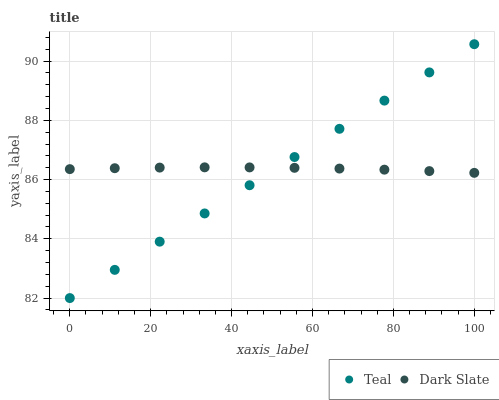Does Teal have the minimum area under the curve?
Answer yes or no. Yes. Does Dark Slate have the maximum area under the curve?
Answer yes or no. Yes. Does Teal have the maximum area under the curve?
Answer yes or no. No. Is Teal the smoothest?
Answer yes or no. Yes. Is Dark Slate the roughest?
Answer yes or no. Yes. Is Teal the roughest?
Answer yes or no. No. Does Teal have the lowest value?
Answer yes or no. Yes. Does Teal have the highest value?
Answer yes or no. Yes. Does Dark Slate intersect Teal?
Answer yes or no. Yes. Is Dark Slate less than Teal?
Answer yes or no. No. Is Dark Slate greater than Teal?
Answer yes or no. No. 